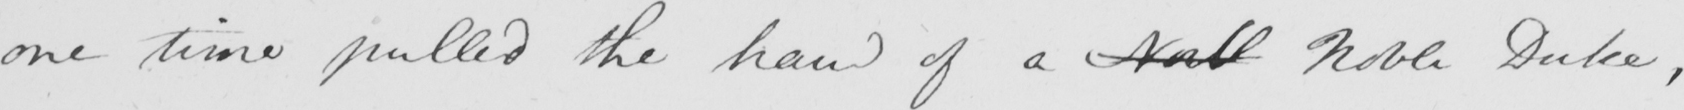Can you tell me what this handwritten text says? one time pulled the hand of a Nobl Noble Duke , 